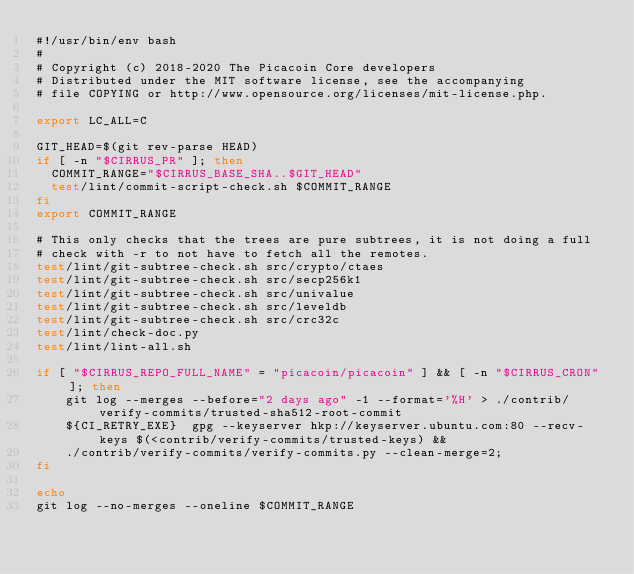Convert code to text. <code><loc_0><loc_0><loc_500><loc_500><_Bash_>#!/usr/bin/env bash
#
# Copyright (c) 2018-2020 The Picacoin Core developers
# Distributed under the MIT software license, see the accompanying
# file COPYING or http://www.opensource.org/licenses/mit-license.php.

export LC_ALL=C

GIT_HEAD=$(git rev-parse HEAD)
if [ -n "$CIRRUS_PR" ]; then
  COMMIT_RANGE="$CIRRUS_BASE_SHA..$GIT_HEAD"
  test/lint/commit-script-check.sh $COMMIT_RANGE
fi
export COMMIT_RANGE

# This only checks that the trees are pure subtrees, it is not doing a full
# check with -r to not have to fetch all the remotes.
test/lint/git-subtree-check.sh src/crypto/ctaes
test/lint/git-subtree-check.sh src/secp256k1
test/lint/git-subtree-check.sh src/univalue
test/lint/git-subtree-check.sh src/leveldb
test/lint/git-subtree-check.sh src/crc32c
test/lint/check-doc.py
test/lint/lint-all.sh

if [ "$CIRRUS_REPO_FULL_NAME" = "picacoin/picacoin" ] && [ -n "$CIRRUS_CRON" ]; then
    git log --merges --before="2 days ago" -1 --format='%H' > ./contrib/verify-commits/trusted-sha512-root-commit
    ${CI_RETRY_EXE}  gpg --keyserver hkp://keyserver.ubuntu.com:80 --recv-keys $(<contrib/verify-commits/trusted-keys) &&
    ./contrib/verify-commits/verify-commits.py --clean-merge=2;
fi

echo
git log --no-merges --oneline $COMMIT_RANGE
</code> 